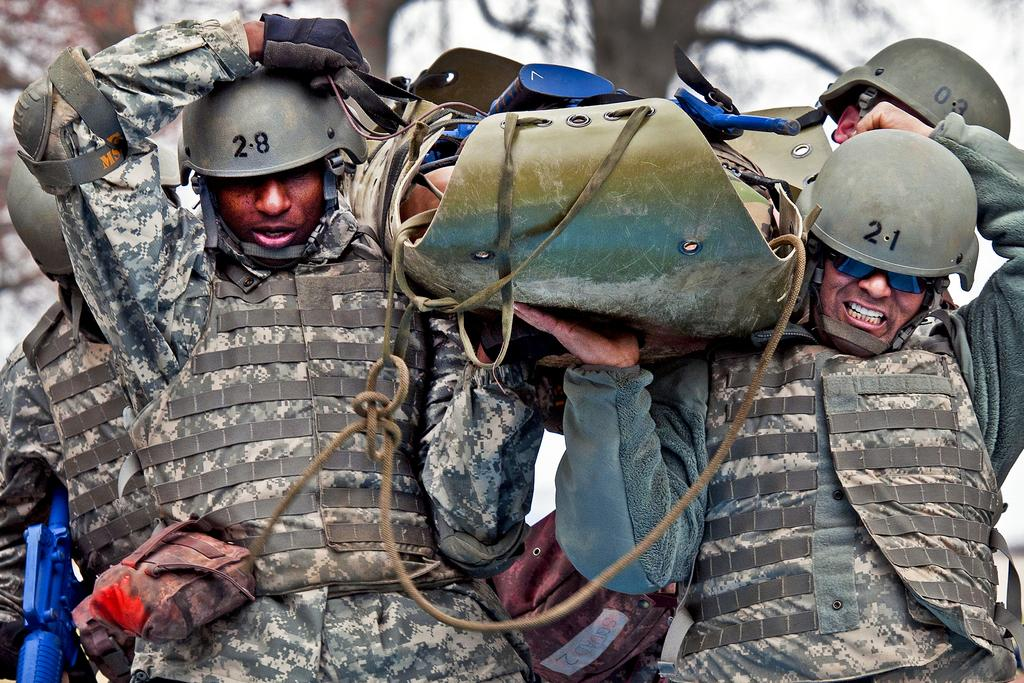What figures are present in the image? There are army men in the image. What are the army men holding in the image? The army men are carrying a plastic thing. What type of clothing are the army men wearing? The army men are wearing army dresses. What type of headgear are the army men wearing? The army men are wearing caps. What type of bit is the army man using to communicate with the horse in the image? There is no horse present in the image, and therefore no bit can be used for communication. 